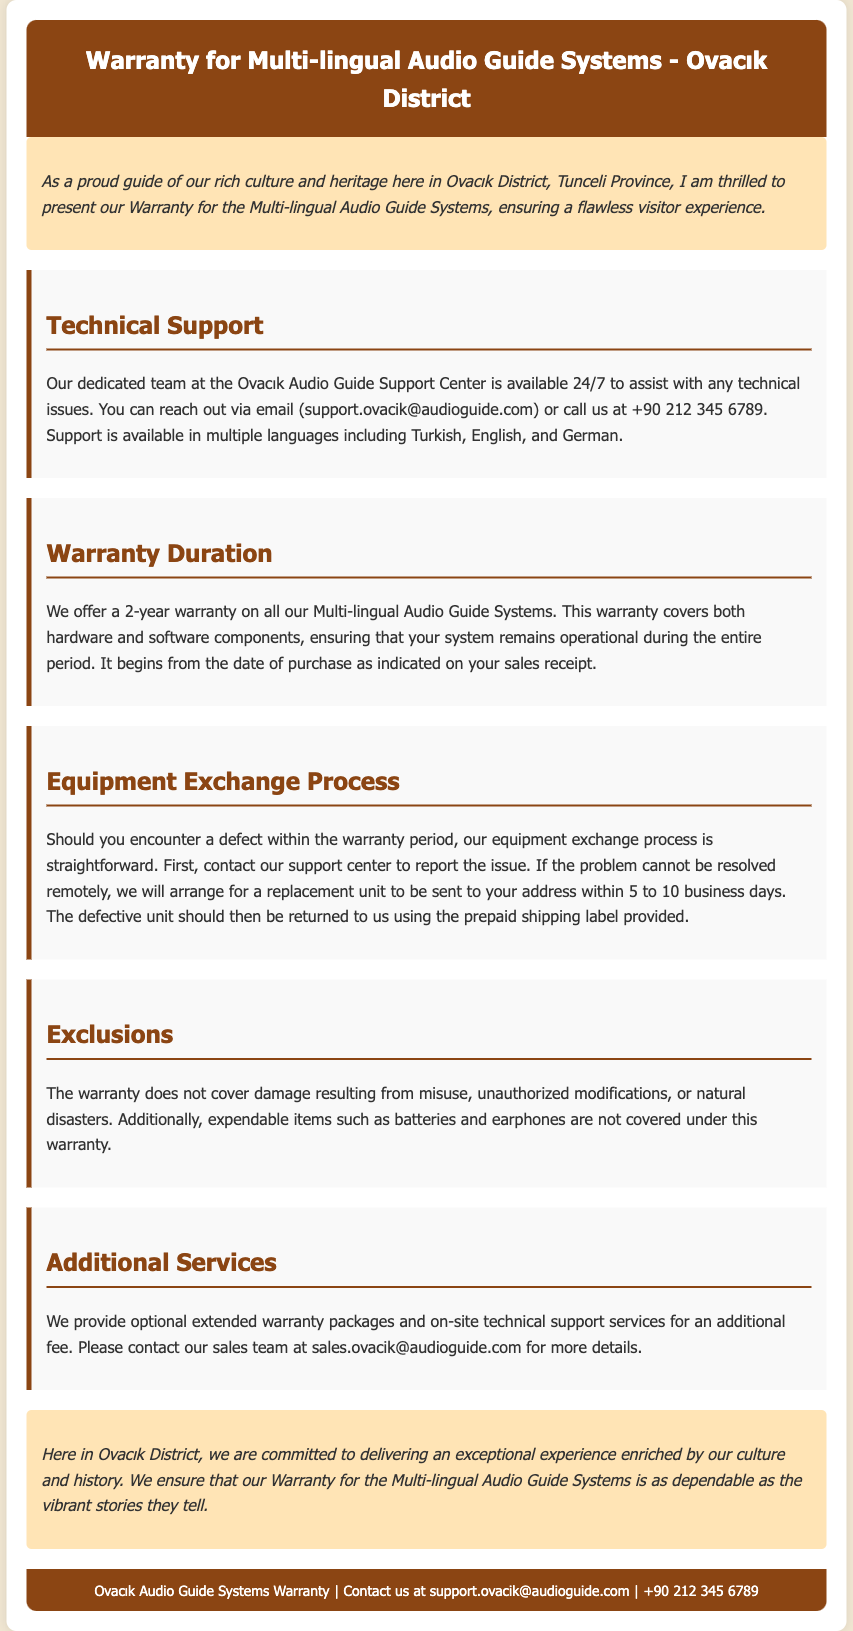What is the warranty duration for the audio guide systems? The document states that the warranty duration is 2 years.
Answer: 2 years What types of support are available? The document mentions technical support via email and phone, available in multiple languages.
Answer: Email and phone support in multiple languages Which team is available 24/7 for technical support? The document specifies the Ovacık Audio Guide Support Center as the team for technical support.
Answer: Ovacık Audio Guide Support Center What should you do if you encounter a defect? According to the document, you should contact the support center to report the issue.
Answer: Contact the support center What items are not covered under the warranty? The document lists damage from misuse and certain expendable items like batteries and earphones as exclusions.
Answer: Misuse, batteries, earphones What is provided if the problem cannot be resolved remotely? The document explains that a replacement unit will be arranged if the issue cannot be solved remotely.
Answer: A replacement unit What is the estimated time for sending a replacement unit? The document states that a replacement unit will be sent within 5 to 10 business days.
Answer: 5 to 10 business days Where can you find additional services information? The document mentions that details on additional services can be obtained by contacting the sales team via email.
Answer: Contact the sales team at email What damage types are excluded from the warranty? The document explicitly mentions damage from unauthorized modifications and natural disasters as exclusions.
Answer: Unauthorized modifications, natural disasters 